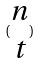Convert formula to latex. <formula><loc_0><loc_0><loc_500><loc_500>( \begin{matrix} n \\ t \end{matrix} )</formula> 